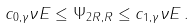<formula> <loc_0><loc_0><loc_500><loc_500>c _ { 0 , \gamma } \nu E \leq \Psi _ { 2 R , R } \leq c _ { 1 , \gamma } \nu E \, .</formula> 